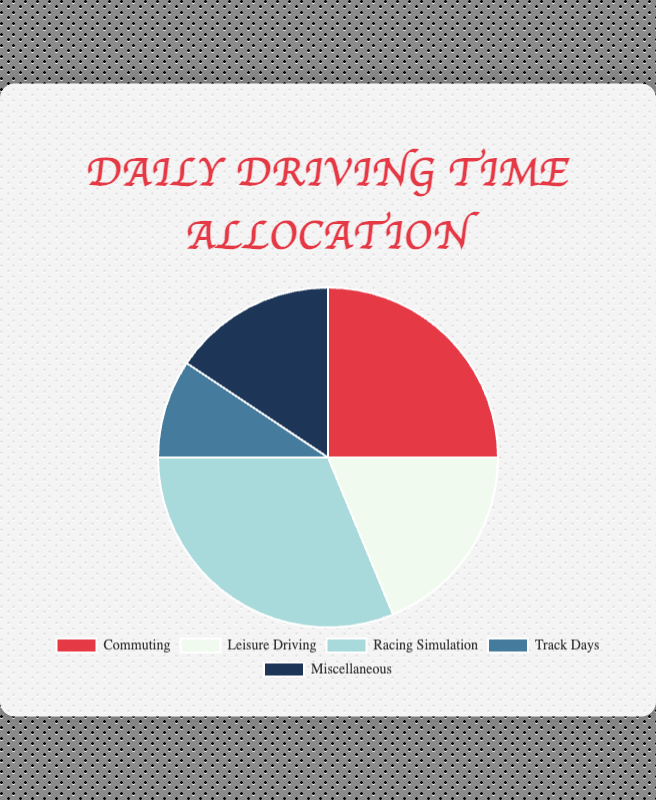Which category has the highest daily driving time? By looking at the pie chart, the largest segment represents the category with the highest daily driving time. Identify the largest segment, which is "Racing Simulation".
Answer: Racing Simulation How much more time do you spend on commuting compared to track days? Locate the segments for "Commuting" and "Track Days" on the pie chart, which are 2 hours and 0.75 hours respectively. Then, subtract the track days time from the commuting time (2.0 - 0.75).
Answer: 1.25 hours What's the total daily driving time spent on commuting and leisure driving combined? Find the segments for "Commuting" and "Leisure Driving". Add their values, which are 2.0 hours and 1.5 hours respectively (2.0 + 1.5).
Answer: 3.5 hours Which category has the smallest allocation of daily driving time? Identify the smallest segment of the pie chart, which corresponds to "Track Days".
Answer: Track Days How many hours are spent on activities other than commuting and racing simulation? First, identify the segments for "Commuting" and "Racing Simulation", which are 2.0 hours and 2.5 hours. Add these values and subtract from total daily time (2.0 + 2.5 = 4.5 hours). Total time is the sum of all categories (2.0+1.5+2.5+0.75+1.25 = 8.0 hours). Subtract 4.5 hours from 8.0 hours.
Answer: 3.5 hours 